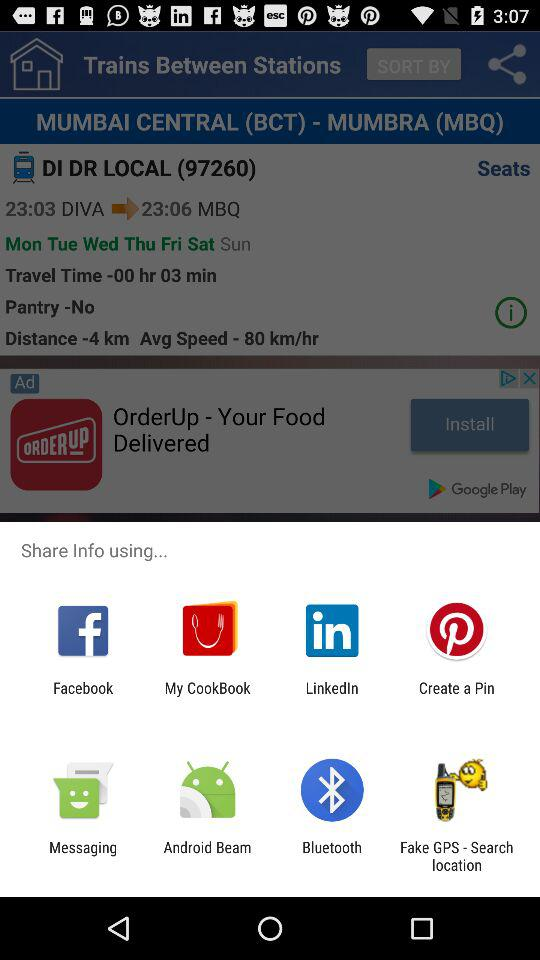What is the shown train number? The shown train number is 97260. 